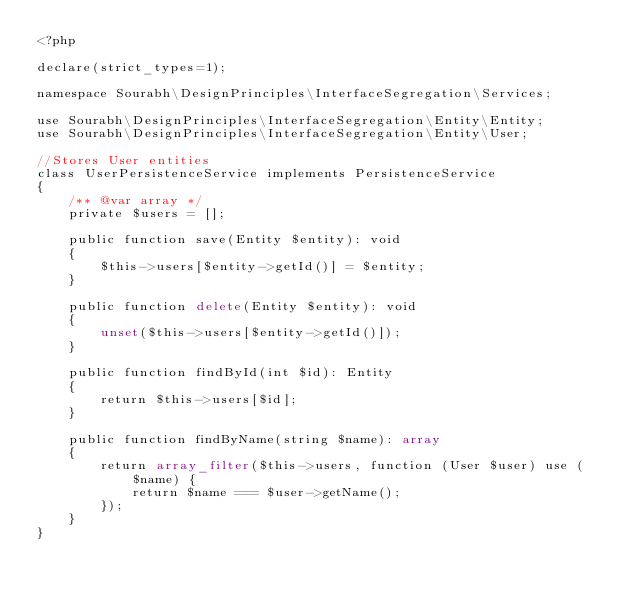Convert code to text. <code><loc_0><loc_0><loc_500><loc_500><_PHP_><?php

declare(strict_types=1);

namespace Sourabh\DesignPrinciples\InterfaceSegregation\Services;

use Sourabh\DesignPrinciples\InterfaceSegregation\Entity\Entity;
use Sourabh\DesignPrinciples\InterfaceSegregation\Entity\User;

//Stores User entities
class UserPersistenceService implements PersistenceService
{
    /** @var array */
    private $users = [];

    public function save(Entity $entity): void
    {
        $this->users[$entity->getId()] = $entity;
    }

    public function delete(Entity $entity): void
    {
        unset($this->users[$entity->getId()]);
    }

    public function findById(int $id): Entity
    {
        return $this->users[$id];
    }

    public function findByName(string $name): array
    {
        return array_filter($this->users, function (User $user) use ($name) {
            return $name === $user->getName();
        });
    }
}
</code> 